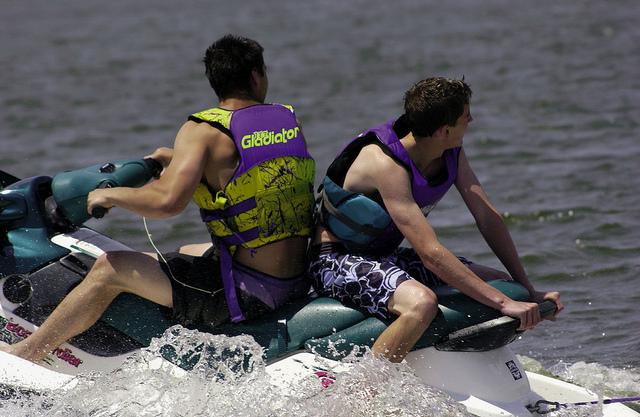What sport is the man in the picture doing?
Be succinct. Jet skiing. What are the individuals wearing on their upper body?
Write a very short answer. Life vests. Are the men facing the same direction?
Write a very short answer. No. Is it cold outside?
Write a very short answer. No. 